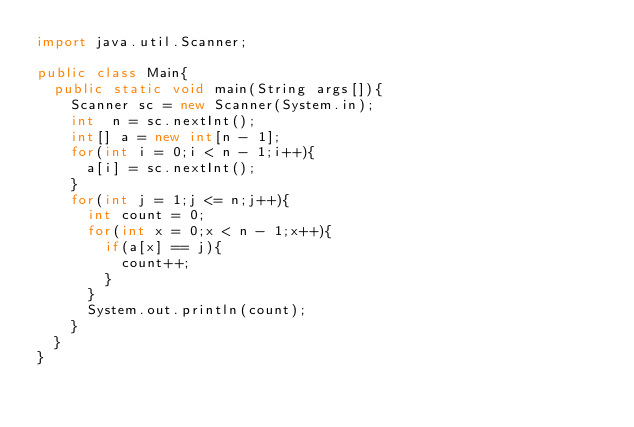<code> <loc_0><loc_0><loc_500><loc_500><_Java_>import java.util.Scanner;

public class Main{
  public static void main(String args[]){
    Scanner sc = new Scanner(System.in);
    int  n = sc.nextInt();   
    int[] a = new int[n - 1];
    for(int i = 0;i < n - 1;i++){
      a[i] = sc.nextInt();
    }
    for(int j = 1;j <= n;j++){
      int count = 0;
      for(int x = 0;x < n - 1;x++){
        if(a[x] == j){
          count++;
        }
      }
      System.out.println(count);
    }
  }
}</code> 